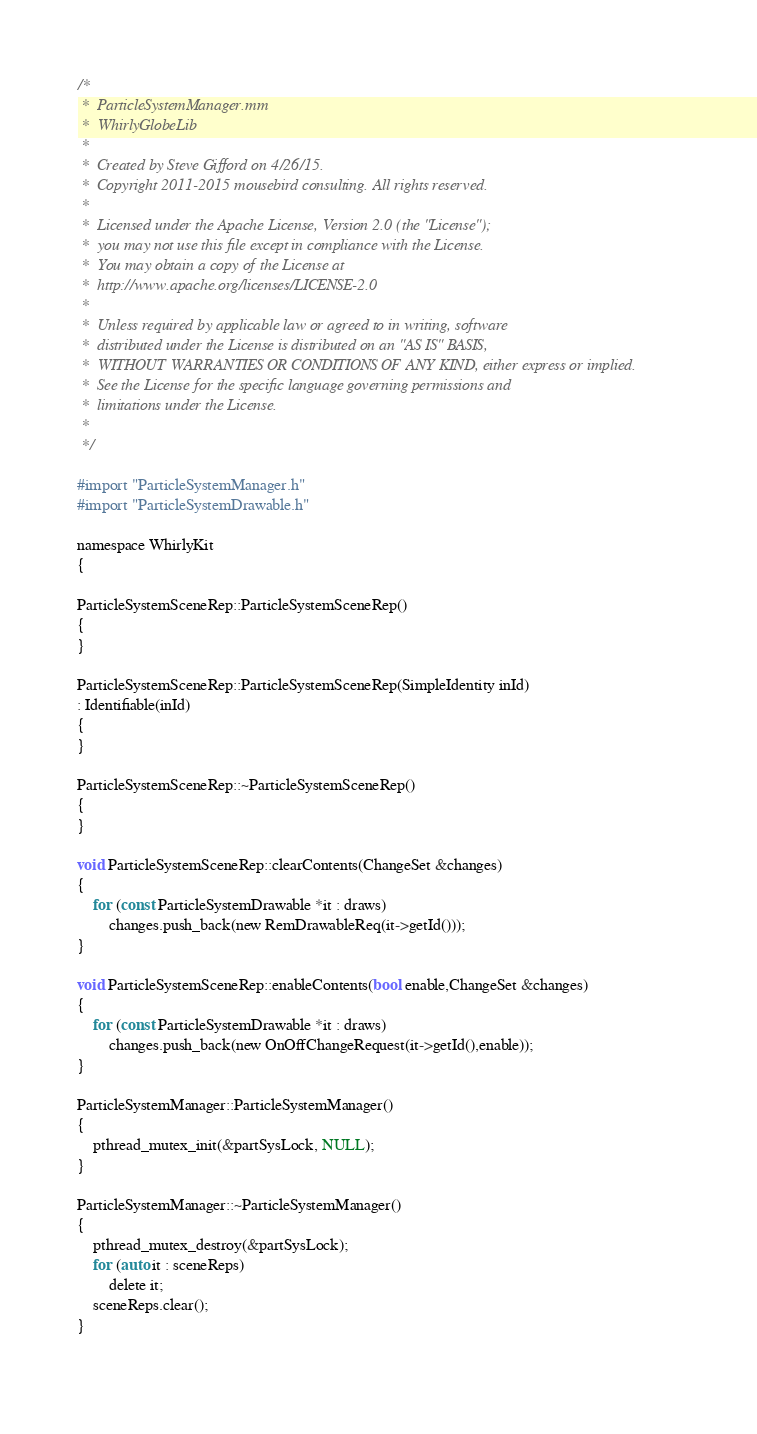Convert code to text. <code><loc_0><loc_0><loc_500><loc_500><_ObjectiveC_>/*
 *  ParticleSystemManager.mm
 *  WhirlyGlobeLib
 *
 *  Created by Steve Gifford on 4/26/15.
 *  Copyright 2011-2015 mousebird consulting. All rights reserved.
 *
 *  Licensed under the Apache License, Version 2.0 (the "License");
 *  you may not use this file except in compliance with the License.
 *  You may obtain a copy of the License at
 *  http://www.apache.org/licenses/LICENSE-2.0
 *
 *  Unless required by applicable law or agreed to in writing, software
 *  distributed under the License is distributed on an "AS IS" BASIS,
 *  WITHOUT WARRANTIES OR CONDITIONS OF ANY KIND, either express or implied.
 *  See the License for the specific language governing permissions and
 *  limitations under the License.
 *
 */

#import "ParticleSystemManager.h"
#import "ParticleSystemDrawable.h"

namespace WhirlyKit
{

ParticleSystemSceneRep::ParticleSystemSceneRep()
{
}

ParticleSystemSceneRep::ParticleSystemSceneRep(SimpleIdentity inId)
: Identifiable(inId)
{
}
    
ParticleSystemSceneRep::~ParticleSystemSceneRep()
{
}
    
void ParticleSystemSceneRep::clearContents(ChangeSet &changes)
{
    for (const ParticleSystemDrawable *it : draws)
        changes.push_back(new RemDrawableReq(it->getId()));
}
    
void ParticleSystemSceneRep::enableContents(bool enable,ChangeSet &changes)
{
    for (const ParticleSystemDrawable *it : draws)
        changes.push_back(new OnOffChangeRequest(it->getId(),enable));
}
    
ParticleSystemManager::ParticleSystemManager()
{
    pthread_mutex_init(&partSysLock, NULL);
}
    
ParticleSystemManager::~ParticleSystemManager()
{
    pthread_mutex_destroy(&partSysLock);
    for (auto it : sceneReps)
        delete it;
    sceneReps.clear();
}
    </code> 